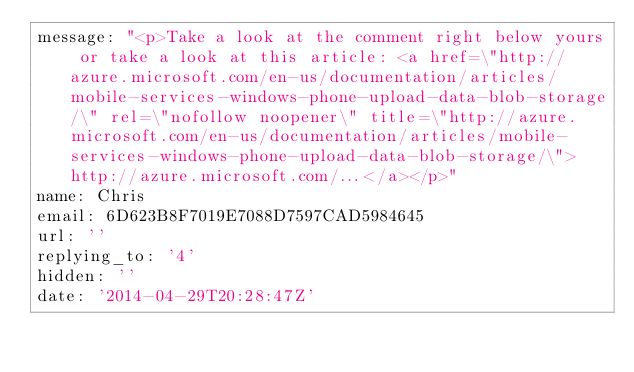<code> <loc_0><loc_0><loc_500><loc_500><_YAML_>message: "<p>Take a look at the comment right below yours or take a look at this article: <a href=\"http://azure.microsoft.com/en-us/documentation/articles/mobile-services-windows-phone-upload-data-blob-storage/\" rel=\"nofollow noopener\" title=\"http://azure.microsoft.com/en-us/documentation/articles/mobile-services-windows-phone-upload-data-blob-storage/\">http://azure.microsoft.com/...</a></p>"
name: Chris
email: 6D623B8F7019E7088D7597CAD5984645
url: ''
replying_to: '4'
hidden: ''
date: '2014-04-29T20:28:47Z'</code> 